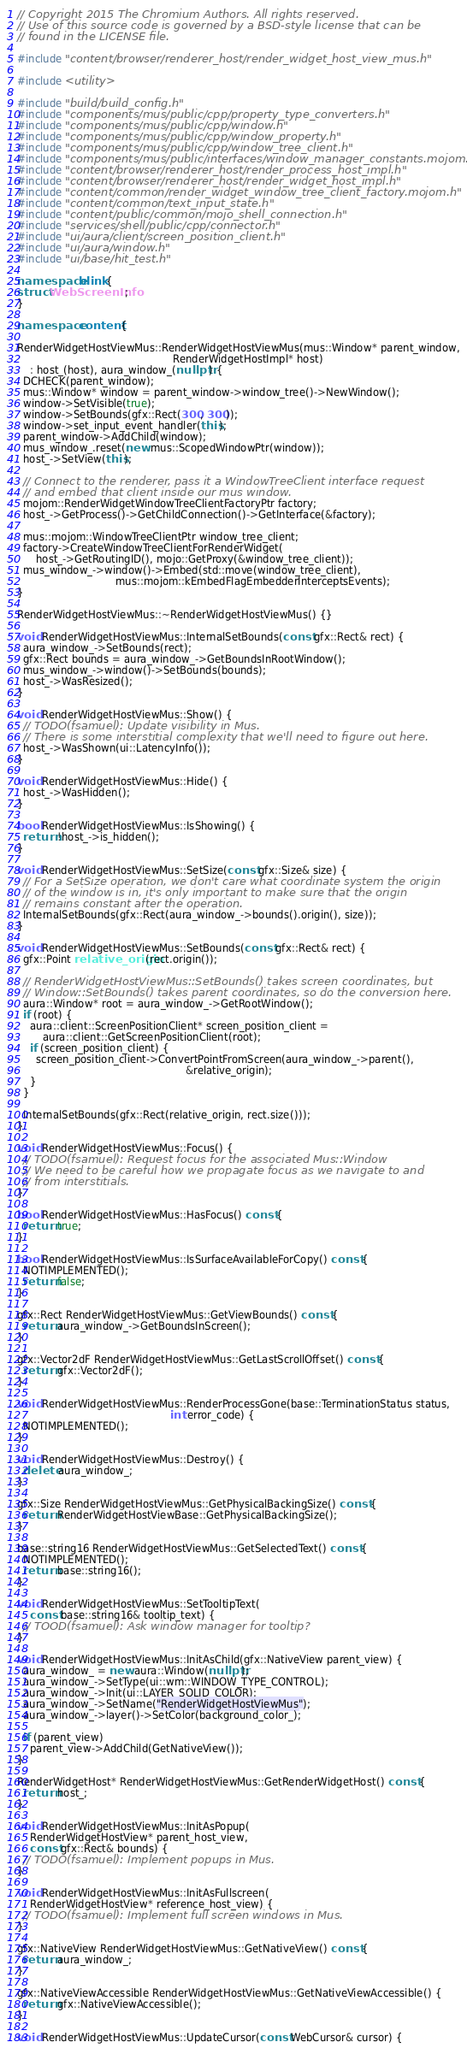Convert code to text. <code><loc_0><loc_0><loc_500><loc_500><_C++_>// Copyright 2015 The Chromium Authors. All rights reserved.
// Use of this source code is governed by a BSD-style license that can be
// found in the LICENSE file.

#include "content/browser/renderer_host/render_widget_host_view_mus.h"

#include <utility>

#include "build/build_config.h"
#include "components/mus/public/cpp/property_type_converters.h"
#include "components/mus/public/cpp/window.h"
#include "components/mus/public/cpp/window_property.h"
#include "components/mus/public/cpp/window_tree_client.h"
#include "components/mus/public/interfaces/window_manager_constants.mojom.h"
#include "content/browser/renderer_host/render_process_host_impl.h"
#include "content/browser/renderer_host/render_widget_host_impl.h"
#include "content/common/render_widget_window_tree_client_factory.mojom.h"
#include "content/common/text_input_state.h"
#include "content/public/common/mojo_shell_connection.h"
#include "services/shell/public/cpp/connector.h"
#include "ui/aura/client/screen_position_client.h"
#include "ui/aura/window.h"
#include "ui/base/hit_test.h"

namespace blink {
struct WebScreenInfo;
}

namespace content {

RenderWidgetHostViewMus::RenderWidgetHostViewMus(mus::Window* parent_window,
                                                 RenderWidgetHostImpl* host)
    : host_(host), aura_window_(nullptr) {
  DCHECK(parent_window);
  mus::Window* window = parent_window->window_tree()->NewWindow();
  window->SetVisible(true);
  window->SetBounds(gfx::Rect(300, 300));
  window->set_input_event_handler(this);
  parent_window->AddChild(window);
  mus_window_.reset(new mus::ScopedWindowPtr(window));
  host_->SetView(this);

  // Connect to the renderer, pass it a WindowTreeClient interface request
  // and embed that client inside our mus window.
  mojom::RenderWidgetWindowTreeClientFactoryPtr factory;
  host_->GetProcess()->GetChildConnection()->GetInterface(&factory);

  mus::mojom::WindowTreeClientPtr window_tree_client;
  factory->CreateWindowTreeClientForRenderWidget(
      host_->GetRoutingID(), mojo::GetProxy(&window_tree_client));
  mus_window_->window()->Embed(std::move(window_tree_client),
                               mus::mojom::kEmbedFlagEmbedderInterceptsEvents);
}

RenderWidgetHostViewMus::~RenderWidgetHostViewMus() {}

void RenderWidgetHostViewMus::InternalSetBounds(const gfx::Rect& rect) {
  aura_window_->SetBounds(rect);
  gfx::Rect bounds = aura_window_->GetBoundsInRootWindow();
  mus_window_->window()->SetBounds(bounds);
  host_->WasResized();
}

void RenderWidgetHostViewMus::Show() {
  // TODO(fsamuel): Update visibility in Mus.
  // There is some interstitial complexity that we'll need to figure out here.
  host_->WasShown(ui::LatencyInfo());
}

void RenderWidgetHostViewMus::Hide() {
  host_->WasHidden();
}

bool RenderWidgetHostViewMus::IsShowing() {
  return !host_->is_hidden();
}

void RenderWidgetHostViewMus::SetSize(const gfx::Size& size) {
  // For a SetSize operation, we don't care what coordinate system the origin
  // of the window is in, it's only important to make sure that the origin
  // remains constant after the operation.
  InternalSetBounds(gfx::Rect(aura_window_->bounds().origin(), size));
}

void RenderWidgetHostViewMus::SetBounds(const gfx::Rect& rect) {
  gfx::Point relative_origin(rect.origin());

  // RenderWidgetHostViewMus::SetBounds() takes screen coordinates, but
  // Window::SetBounds() takes parent coordinates, so do the conversion here.
  aura::Window* root = aura_window_->GetRootWindow();
  if (root) {
    aura::client::ScreenPositionClient* screen_position_client =
        aura::client::GetScreenPositionClient(root);
    if (screen_position_client) {
      screen_position_client->ConvertPointFromScreen(aura_window_->parent(),
                                                     &relative_origin);
    }
  }

  InternalSetBounds(gfx::Rect(relative_origin, rect.size()));
}

void RenderWidgetHostViewMus::Focus() {
  // TODO(fsamuel): Request focus for the associated Mus::Window
  // We need to be careful how we propagate focus as we navigate to and
  // from interstitials.
}

bool RenderWidgetHostViewMus::HasFocus() const {
  return true;
}

bool RenderWidgetHostViewMus::IsSurfaceAvailableForCopy() const {
  NOTIMPLEMENTED();
  return false;
}

gfx::Rect RenderWidgetHostViewMus::GetViewBounds() const {
  return aura_window_->GetBoundsInScreen();
}

gfx::Vector2dF RenderWidgetHostViewMus::GetLastScrollOffset() const {
  return gfx::Vector2dF();
}

void RenderWidgetHostViewMus::RenderProcessGone(base::TerminationStatus status,
                                                int error_code) {
  NOTIMPLEMENTED();
}

void RenderWidgetHostViewMus::Destroy() {
  delete aura_window_;
}

gfx::Size RenderWidgetHostViewMus::GetPhysicalBackingSize() const {
  return RenderWidgetHostViewBase::GetPhysicalBackingSize();
}

base::string16 RenderWidgetHostViewMus::GetSelectedText() const {
  NOTIMPLEMENTED();
  return base::string16();
}

void RenderWidgetHostViewMus::SetTooltipText(
    const base::string16& tooltip_text) {
  // TOOD(fsamuel): Ask window manager for tooltip?
}

void RenderWidgetHostViewMus::InitAsChild(gfx::NativeView parent_view) {
  aura_window_ = new aura::Window(nullptr);
  aura_window_->SetType(ui::wm::WINDOW_TYPE_CONTROL);
  aura_window_->Init(ui::LAYER_SOLID_COLOR);
  aura_window_->SetName("RenderWidgetHostViewMus");
  aura_window_->layer()->SetColor(background_color_);

  if (parent_view)
    parent_view->AddChild(GetNativeView());
}

RenderWidgetHost* RenderWidgetHostViewMus::GetRenderWidgetHost() const {
  return host_;
}

void RenderWidgetHostViewMus::InitAsPopup(
    RenderWidgetHostView* parent_host_view,
    const gfx::Rect& bounds) {
  // TODO(fsamuel): Implement popups in Mus.
}

void RenderWidgetHostViewMus::InitAsFullscreen(
    RenderWidgetHostView* reference_host_view) {
  // TODO(fsamuel): Implement full screen windows in Mus.
}

gfx::NativeView RenderWidgetHostViewMus::GetNativeView() const {
  return aura_window_;
}

gfx::NativeViewAccessible RenderWidgetHostViewMus::GetNativeViewAccessible() {
  return gfx::NativeViewAccessible();
}

void RenderWidgetHostViewMus::UpdateCursor(const WebCursor& cursor) {</code> 